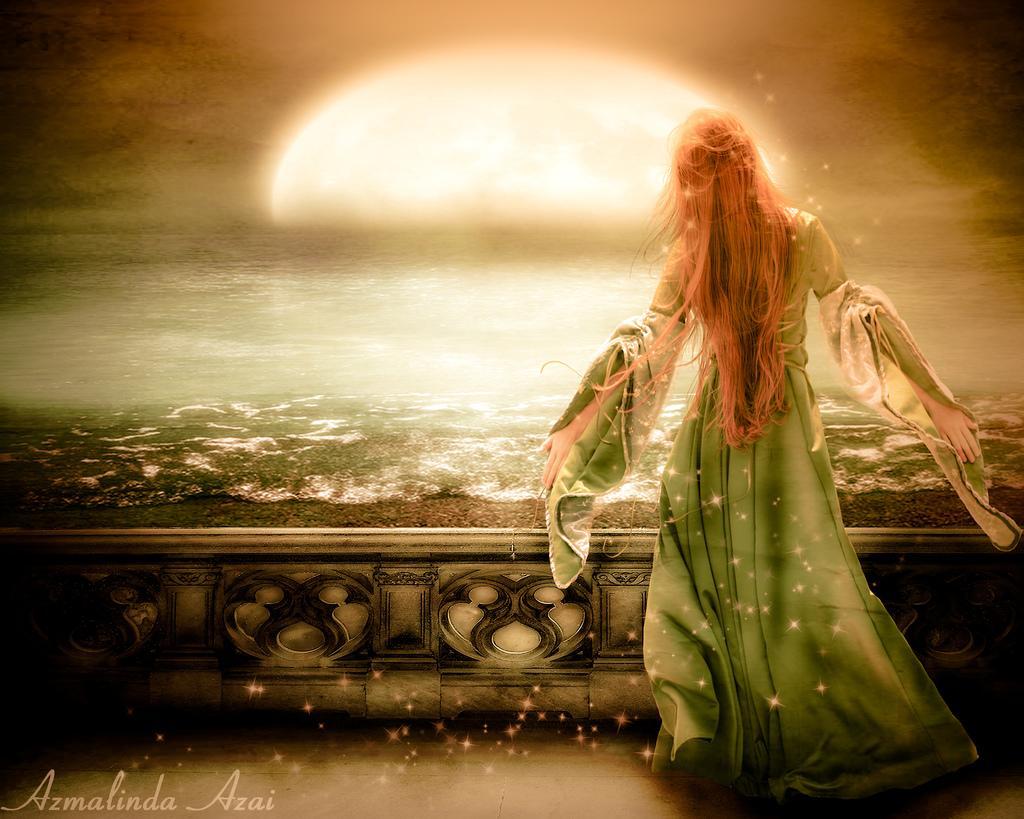Could you give a brief overview of what you see in this image? In this picture, we can see an animated image, we can see the ground, a lady, and some text in the bottom left corner. 